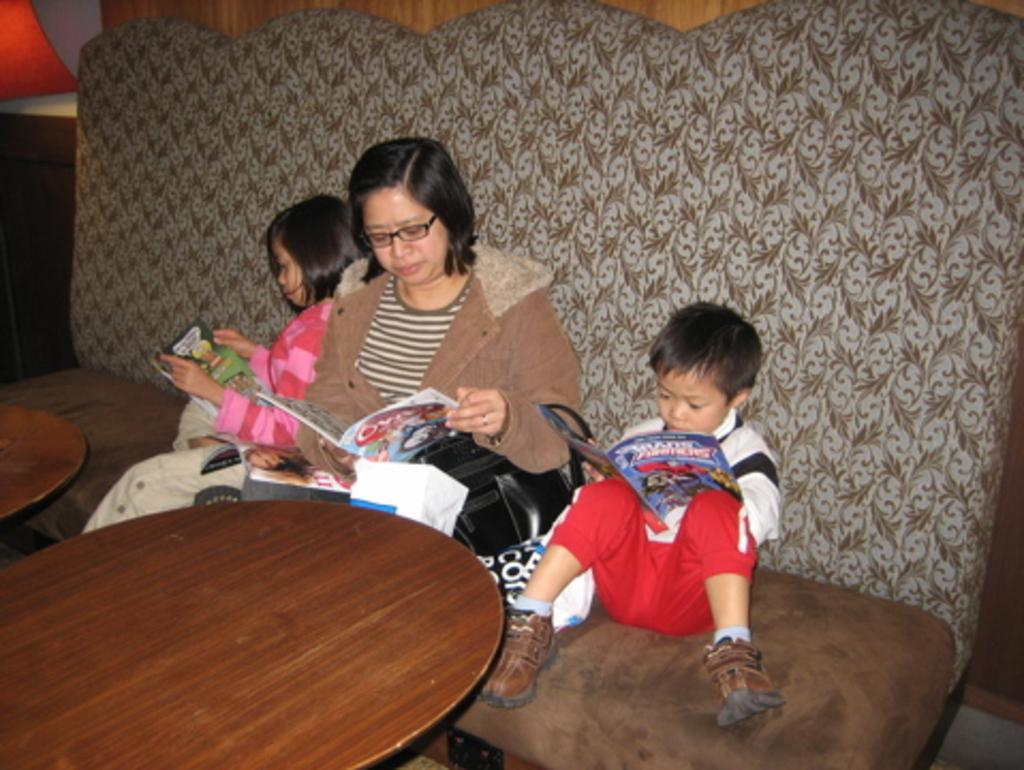What are the people in the image doing? The people in the image are sitting. What objects are the people holding in the image? The people are holding books. How many girls are present in the image? The provided facts do not mention the gender of the people in the image, so it is impossible to determine the number of girls. 